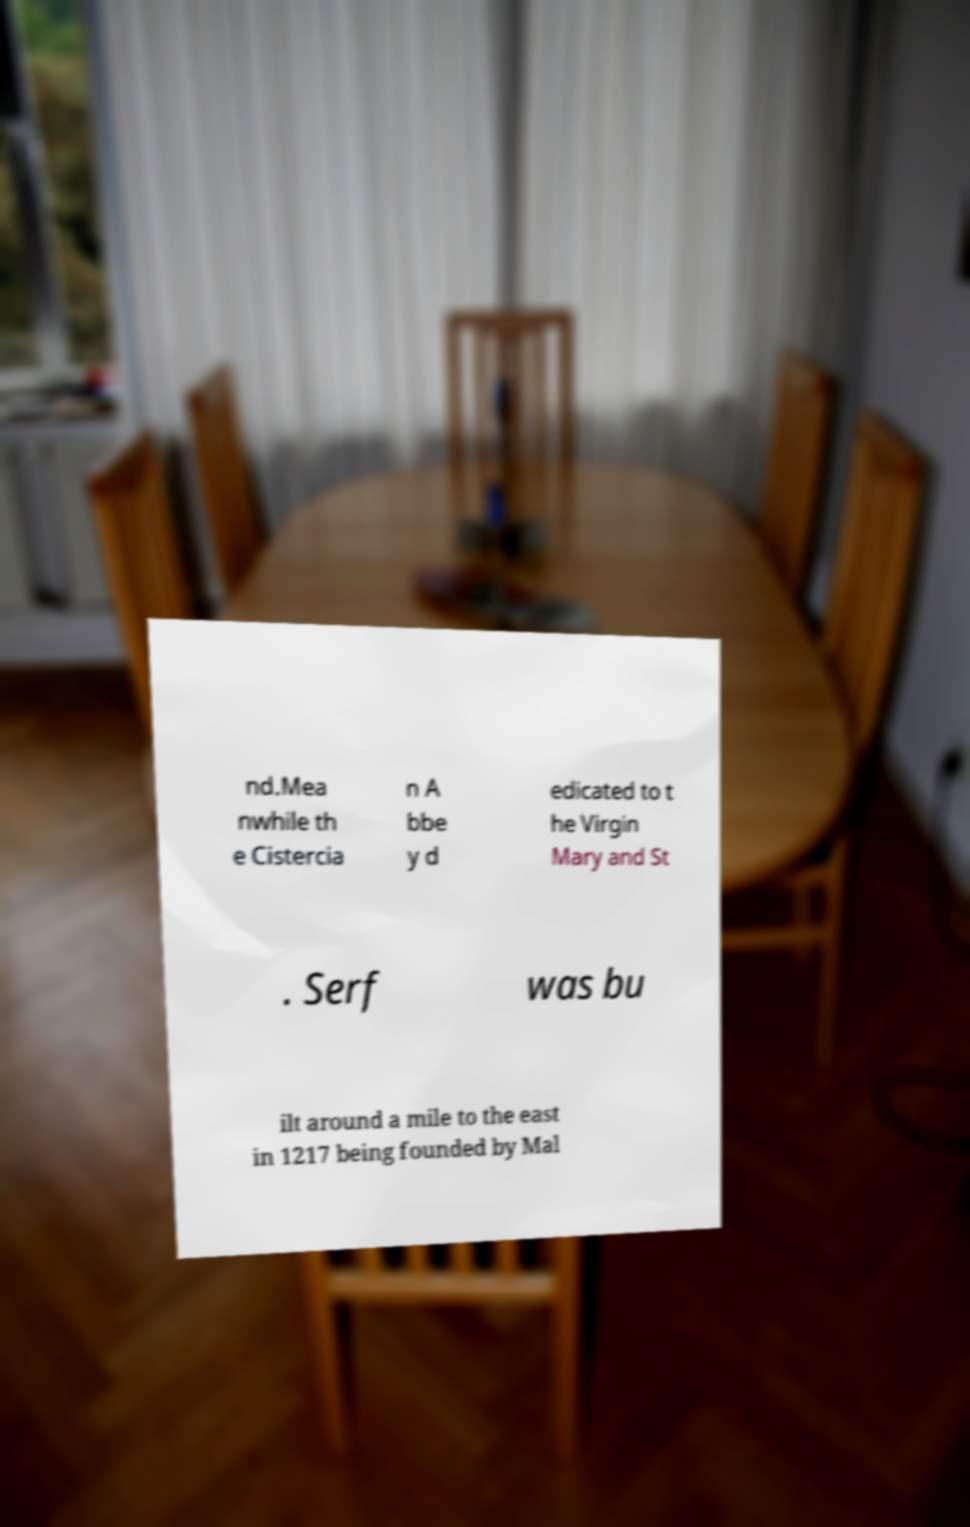Can you accurately transcribe the text from the provided image for me? nd.Mea nwhile th e Cistercia n A bbe y d edicated to t he Virgin Mary and St . Serf was bu ilt around a mile to the east in 1217 being founded by Mal 